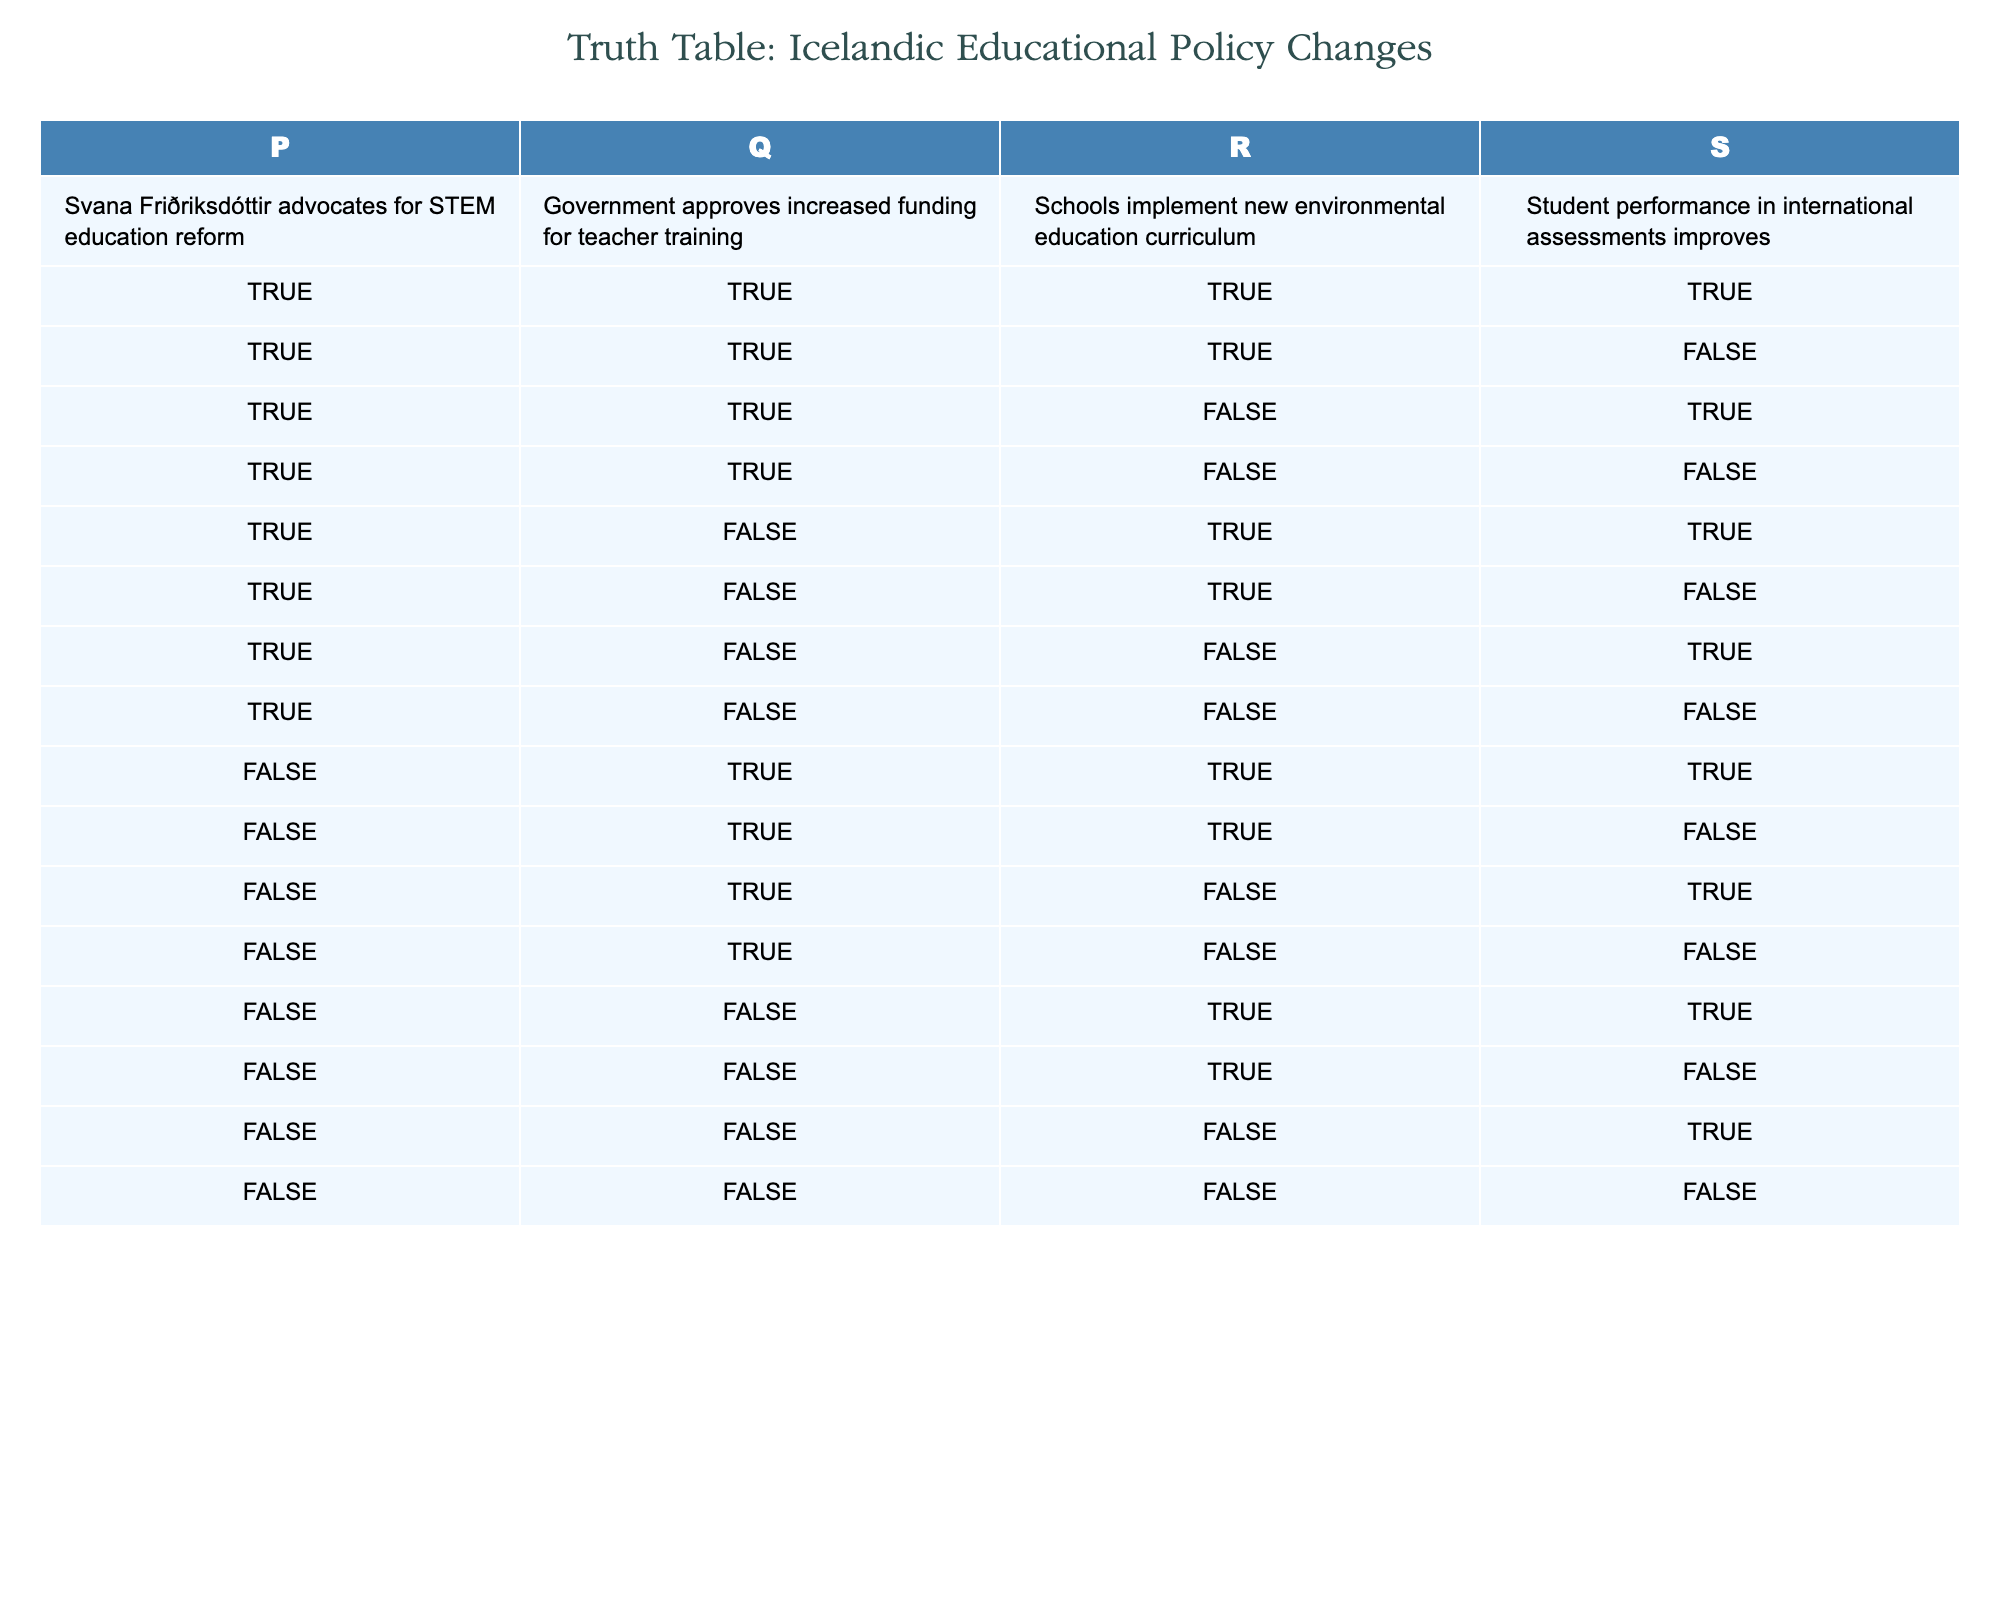What percentage of scenarios led to improved student performance? First, count the total scenarios, which is 16 rows. Next, identify the rows where student performance improves, which occurs in 8 scenarios (the first four rows and the 8th row). Calculate the percentage: (8/16) * 100 = 50%.
Answer: 50% Was there any scenario where STEM education reform was advocated, teacher training was funded, but student performance did not improve? Look for rows where both "Svana Friðriksdóttir advocates for STEM education reform" and "Government approves increased funding for teacher training" are true (which only occurs when P and Q are true). In these cases, check if R is false, which occurs in the second row.
Answer: Yes How many instances had an environmental education curriculum implemented and where student performance did not improve? Count the rows where "Schools implement new environmental education curriculum" (S is true), and then find the scenarios where "Student performance improves" (R is false). This is true for 2 scenarios: the second row and the fourth row.
Answer: 2 If the government does not approve funding for teacher training, how often did student performance improve? Ideally, we check all rows where "Government approves increased funding for teacher training" (Q is false). There are 8 such rows in the table, of which only 2 result in improved student performance (rows 5 and 12). Calculate the percentage: (2/8) * 100 = 25%.
Answer: 25% Was there a situation where both STEM education reform was advocated and environmental education was implemented, but there was no improvement in student performance? Inspect the rows where both "Svana Friðriksdóttir advocates for STEM education reform" (P is true) and "Schools implement new environmental education curriculum" (S is true) are true. This occurs in three scenarios (1st, 3rd, 8th) but only the 3rd row has improved performance being false.
Answer: Yes 